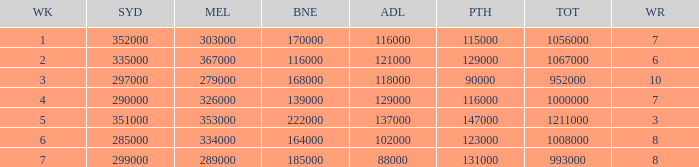How many Adelaide viewers were there in Week 5? 137000.0. I'm looking to parse the entire table for insights. Could you assist me with that? {'header': ['WK', 'SYD', 'MEL', 'BNE', 'ADL', 'PTH', 'TOT', 'WR'], 'rows': [['1', '352000', '303000', '170000', '116000', '115000', '1056000', '7'], ['2', '335000', '367000', '116000', '121000', '129000', '1067000', '6'], ['3', '297000', '279000', '168000', '118000', '90000', '952000', '10'], ['4', '290000', '326000', '139000', '129000', '116000', '1000000', '7'], ['5', '351000', '353000', '222000', '137000', '147000', '1211000', '3'], ['6', '285000', '334000', '164000', '102000', '123000', '1008000', '8'], ['7', '299000', '289000', '185000', '88000', '131000', '993000', '8']]} 